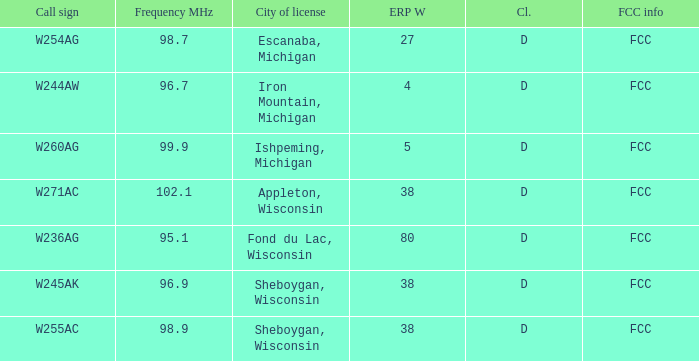What was the class for Appleton, Wisconsin? D. 